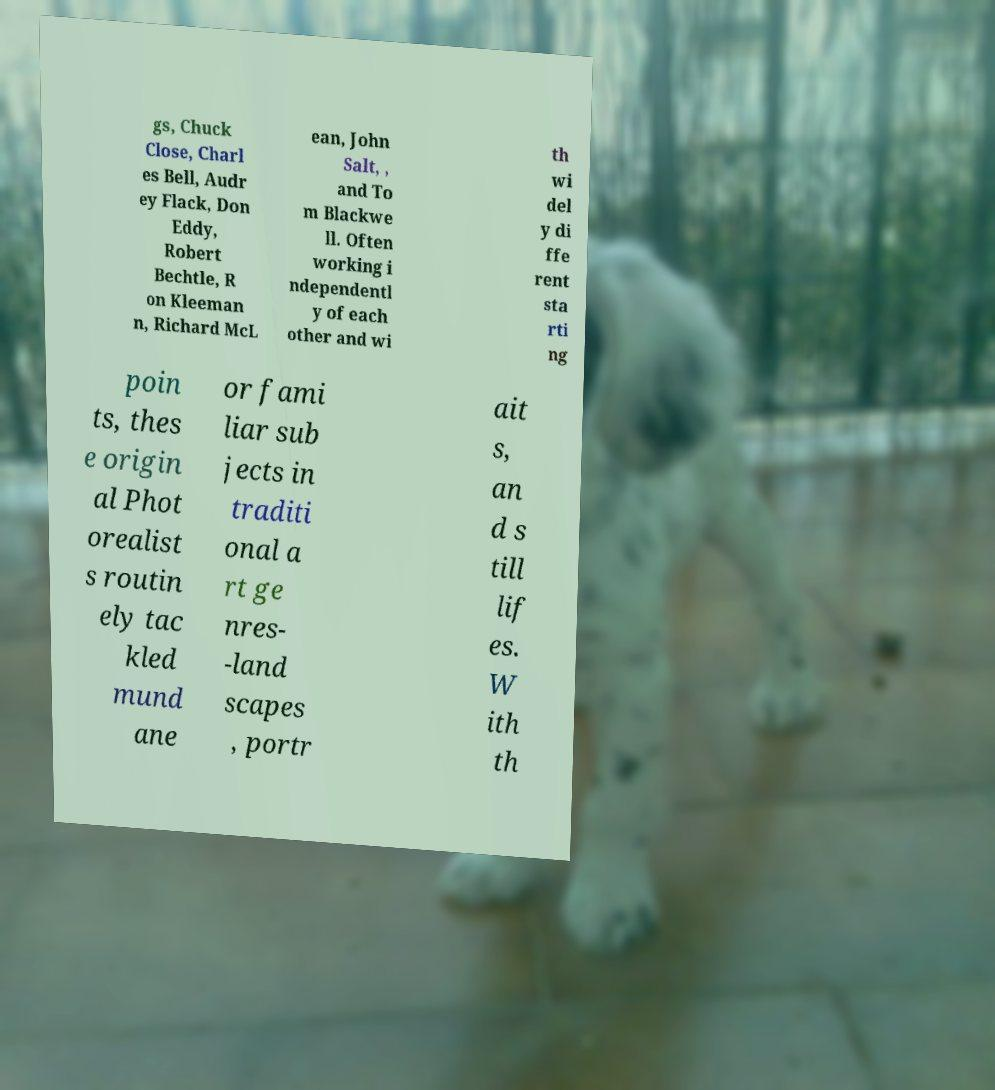I need the written content from this picture converted into text. Can you do that? gs, Chuck Close, Charl es Bell, Audr ey Flack, Don Eddy, Robert Bechtle, R on Kleeman n, Richard McL ean, John Salt, , and To m Blackwe ll. Often working i ndependentl y of each other and wi th wi del y di ffe rent sta rti ng poin ts, thes e origin al Phot orealist s routin ely tac kled mund ane or fami liar sub jects in traditi onal a rt ge nres- -land scapes , portr ait s, an d s till lif es. W ith th 